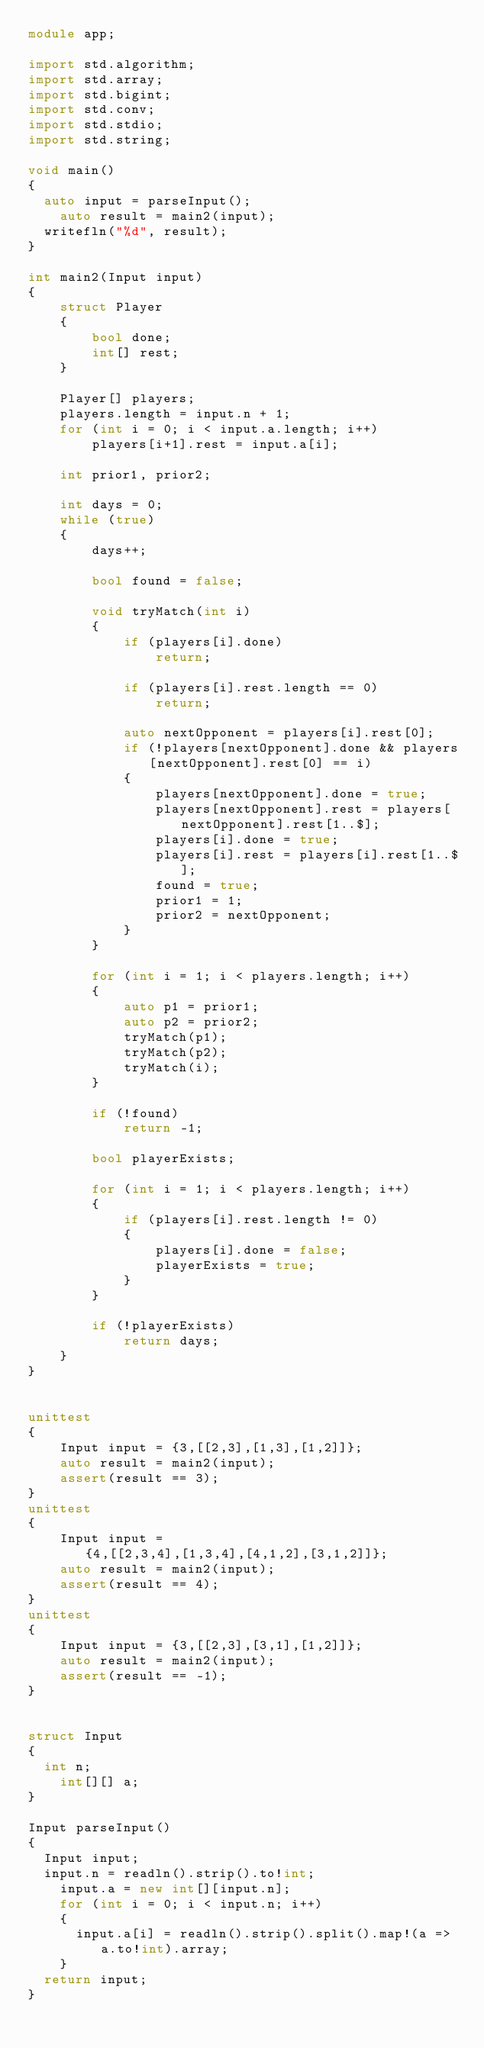<code> <loc_0><loc_0><loc_500><loc_500><_D_>module app;

import std.algorithm;
import std.array;
import std.bigint;
import std.conv;
import std.stdio;
import std.string;

void main()
{
	auto input = parseInput();
    auto result = main2(input);	
	writefln("%d", result);
}

int main2(Input input)
{
    struct Player
    {
        bool done;
        int[] rest;
    }

    Player[] players;
    players.length = input.n + 1;
    for (int i = 0; i < input.a.length; i++)
        players[i+1].rest = input.a[i];

    int prior1, prior2;

    int days = 0;
    while (true)
    {
        days++;

        bool found = false;

        void tryMatch(int i)
        {
            if (players[i].done)
                return;

            if (players[i].rest.length == 0)
                return;

            auto nextOpponent = players[i].rest[0];
            if (!players[nextOpponent].done && players[nextOpponent].rest[0] == i)
            {
                players[nextOpponent].done = true;
                players[nextOpponent].rest = players[nextOpponent].rest[1..$];
                players[i].done = true;
                players[i].rest = players[i].rest[1..$];
                found = true;
                prior1 = 1;
                prior2 = nextOpponent;
            }
        }

        for (int i = 1; i < players.length; i++)
        {
            auto p1 = prior1;
            auto p2 = prior2;
            tryMatch(p1);
            tryMatch(p2);
            tryMatch(i);
        }

        if (!found)
            return -1;

        bool playerExists;

        for (int i = 1; i < players.length; i++)
        {
            if (players[i].rest.length != 0)
            {
                players[i].done = false;
                playerExists = true;
            }
        }

        if (!playerExists)
            return days;
    }
}


unittest
{
    Input input = {3,[[2,3],[1,3],[1,2]]};
    auto result = main2(input);
    assert(result == 3);
}
unittest
{
    Input input = {4,[[2,3,4],[1,3,4],[4,1,2],[3,1,2]]};
    auto result = main2(input);
    assert(result == 4);
}
unittest
{
    Input input = {3,[[2,3],[3,1],[1,2]]};
    auto result = main2(input);
    assert(result == -1);
}


struct Input
{
	int n;
    int[][] a;
}

Input parseInput()
{
	Input input;
	input.n = readln().strip().to!int;
    input.a = new int[][input.n];
    for (int i = 0; i < input.n; i++)
    {
    	input.a[i] = readln().strip().split().map!(a => a.to!int).array;
    }
	return input;
}
</code> 